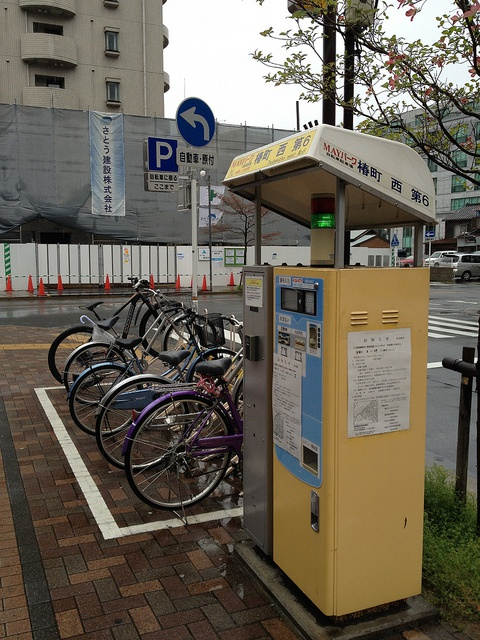Describe the objects in this image and their specific colors. I can see parking meter in gray and olive tones, bicycle in gray and black tones, bicycle in gray and black tones, bicycle in gray, black, and darkgray tones, and bicycle in gray and black tones in this image. 